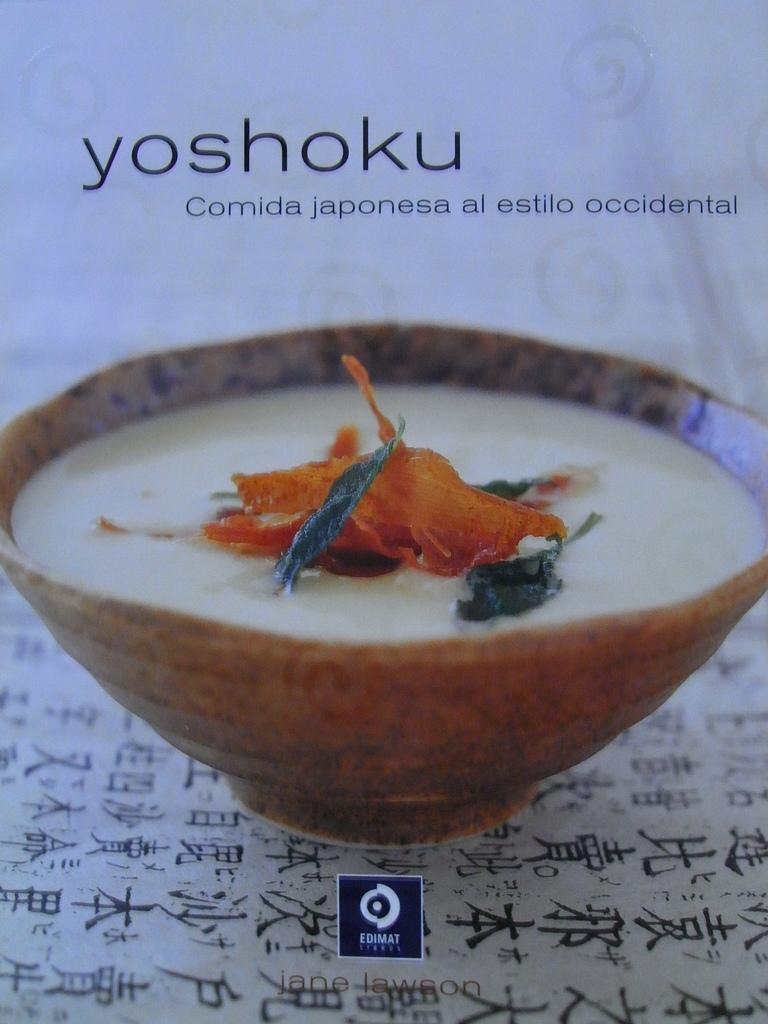How would you summarize this image in a sentence or two? In this image in the center there is one bowl, in the bowl there is some food. And at the bottom it looks like a table, at the top there is text and at the bottom of the image there is one logo. 